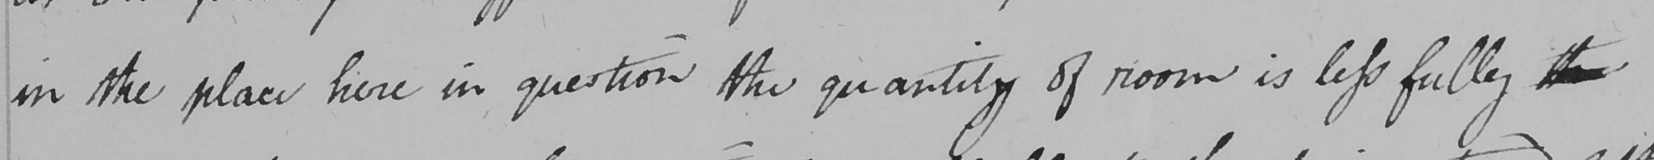What text is written in this handwritten line? in the place here in question the quantity of room is less fully  <gap/> 